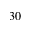<formula> <loc_0><loc_0><loc_500><loc_500>3 0</formula> 